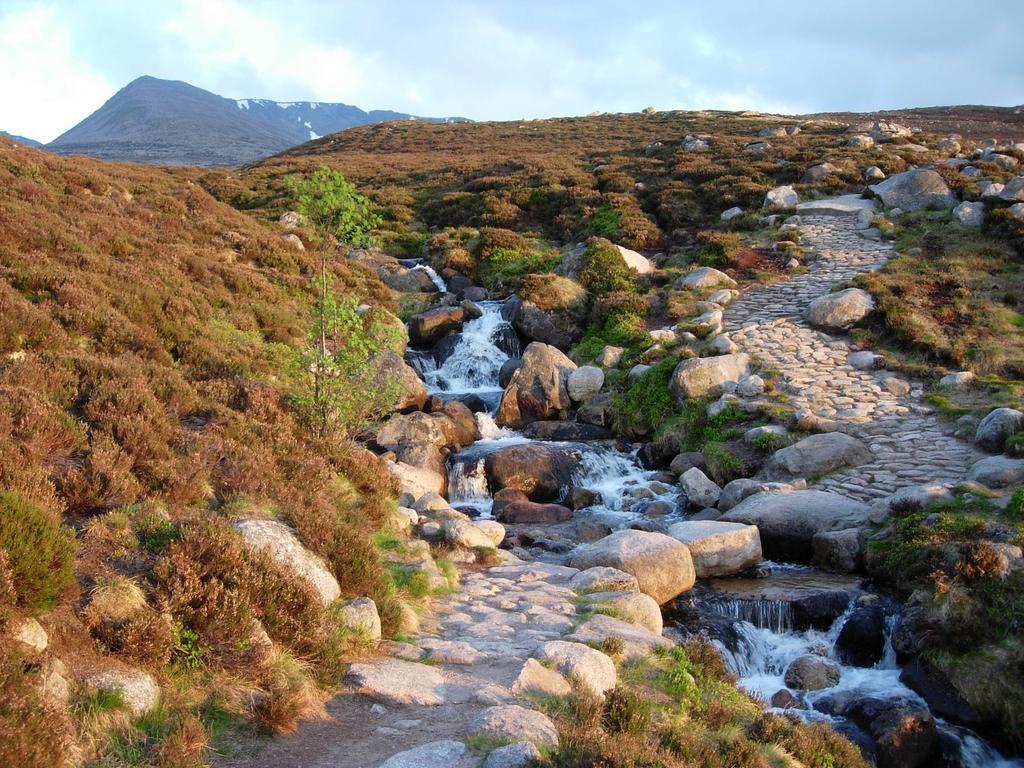Could you give a brief overview of what you see in this image? In this image we can see a stream, rocks and greenery. At the top of the image, we can see the sky with clouds and a mountain. 